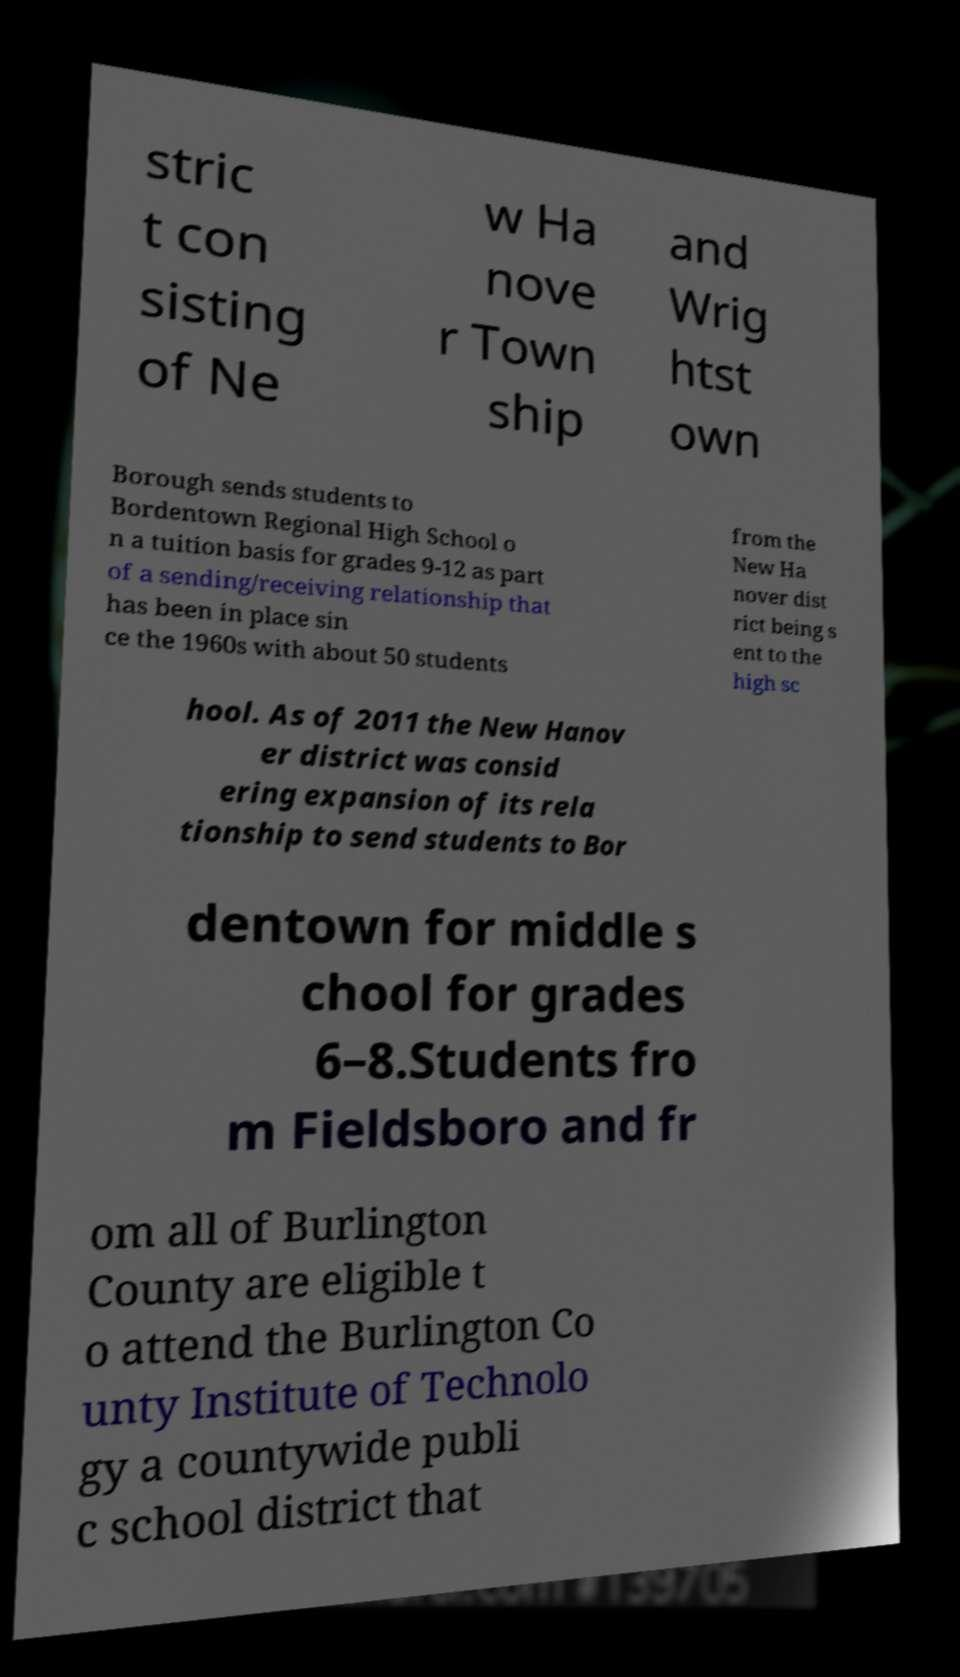There's text embedded in this image that I need extracted. Can you transcribe it verbatim? stric t con sisting of Ne w Ha nove r Town ship and Wrig htst own Borough sends students to Bordentown Regional High School o n a tuition basis for grades 9-12 as part of a sending/receiving relationship that has been in place sin ce the 1960s with about 50 students from the New Ha nover dist rict being s ent to the high sc hool. As of 2011 the New Hanov er district was consid ering expansion of its rela tionship to send students to Bor dentown for middle s chool for grades 6–8.Students fro m Fieldsboro and fr om all of Burlington County are eligible t o attend the Burlington Co unty Institute of Technolo gy a countywide publi c school district that 